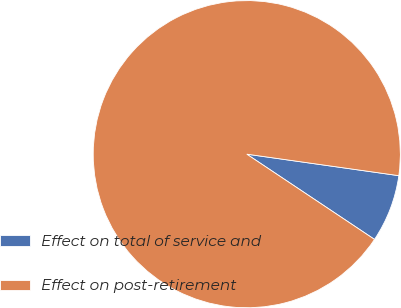<chart> <loc_0><loc_0><loc_500><loc_500><pie_chart><fcel>Effect on total of service and<fcel>Effect on post-retirement<nl><fcel>7.13%<fcel>92.87%<nl></chart> 